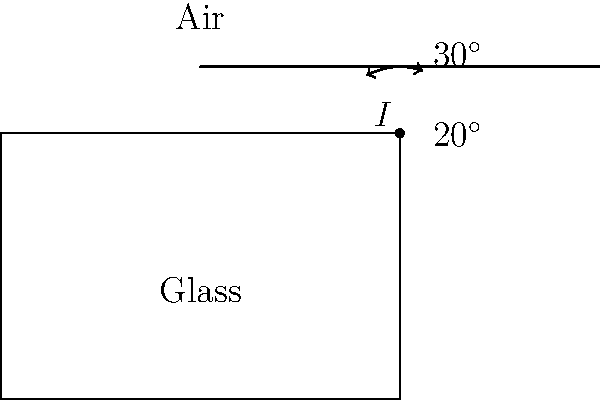In a military reconnaissance operation, you're tasked with calibrating an optical device that uses a glass prism. A light ray enters the prism at point $I$ as shown in the diagram, with an angle of incidence of $30^\circ$. If the angle of refraction inside the glass is $20^\circ$, calculate the refractive index of the glass. Assume the refractive index of air is 1.0. To solve this problem, we'll use Snell's law, which relates the angles of incidence and refraction to the refractive indices of the media:

$$\frac{\sin \theta_1}{\sin \theta_2} = \frac{n_2}{n_1}$$

Where:
$\theta_1$ is the angle of incidence in air
$\theta_2$ is the angle of refraction in glass
$n_1$ is the refractive index of air (given as 1.0)
$n_2$ is the refractive index of glass (what we need to find)

Step 1: Identify the known values
$\theta_1 = 30^\circ$
$\theta_2 = 20^\circ$
$n_1 = 1.0$

Step 2: Substitute these values into Snell's law
$$\frac{\sin 30^\circ}{\sin 20^\circ} = \frac{n_2}{1.0}$$

Step 3: Simplify the left side of the equation
$$\frac{0.5}{0.3420} = n_2$$

Step 4: Calculate the refractive index of glass
$$n_2 = 1.4619$$

Therefore, the refractive index of the glass used in the optical device is approximately 1.46.
Answer: 1.46 